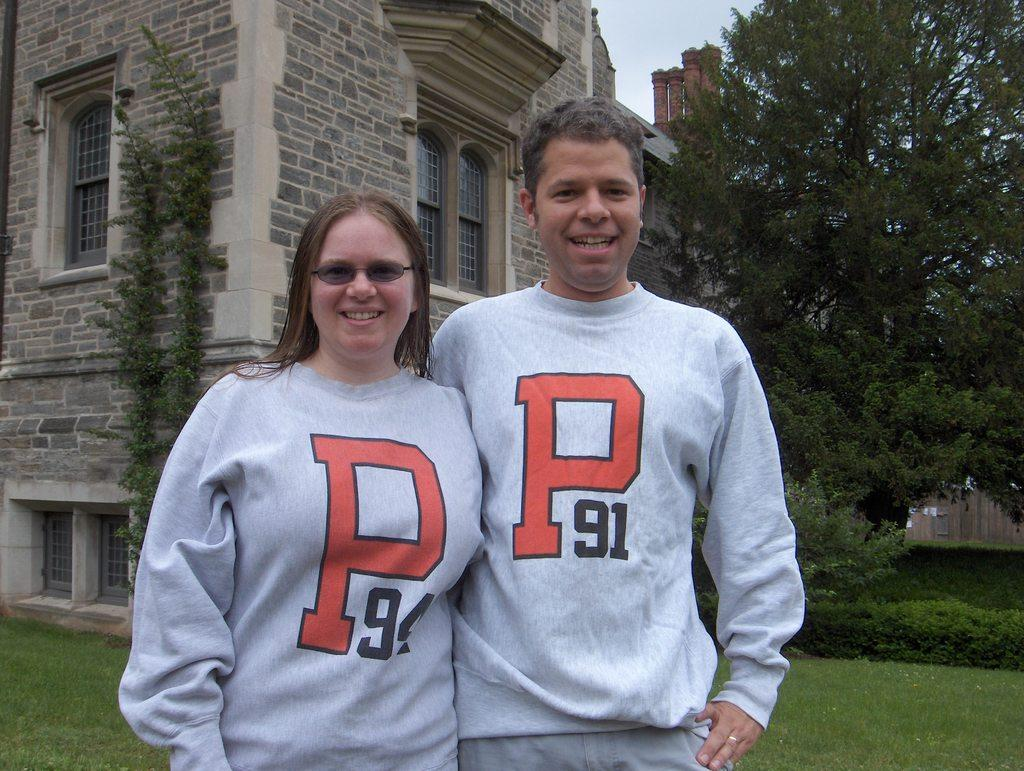<image>
Offer a succinct explanation of the picture presented. A man and woman standing together are wearing matching sweatshirts with a P on the front. 